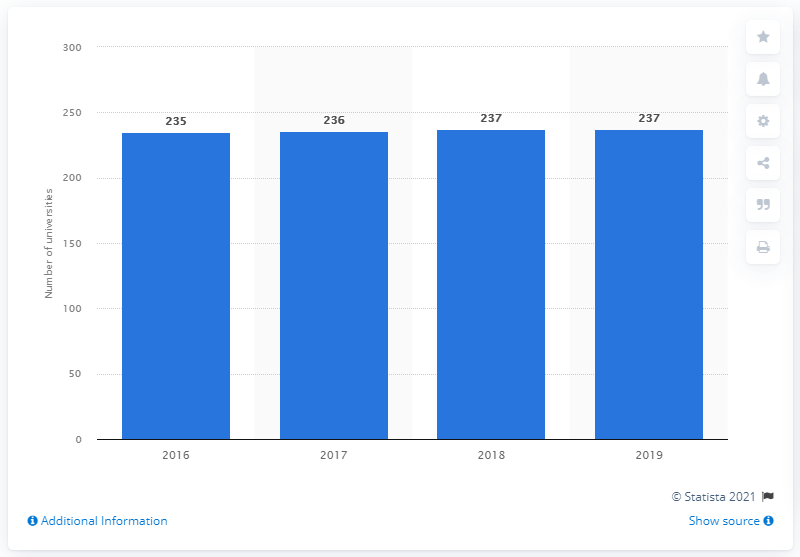Identify some key points in this picture. There were 237 universities in Vietnam in 2019. 